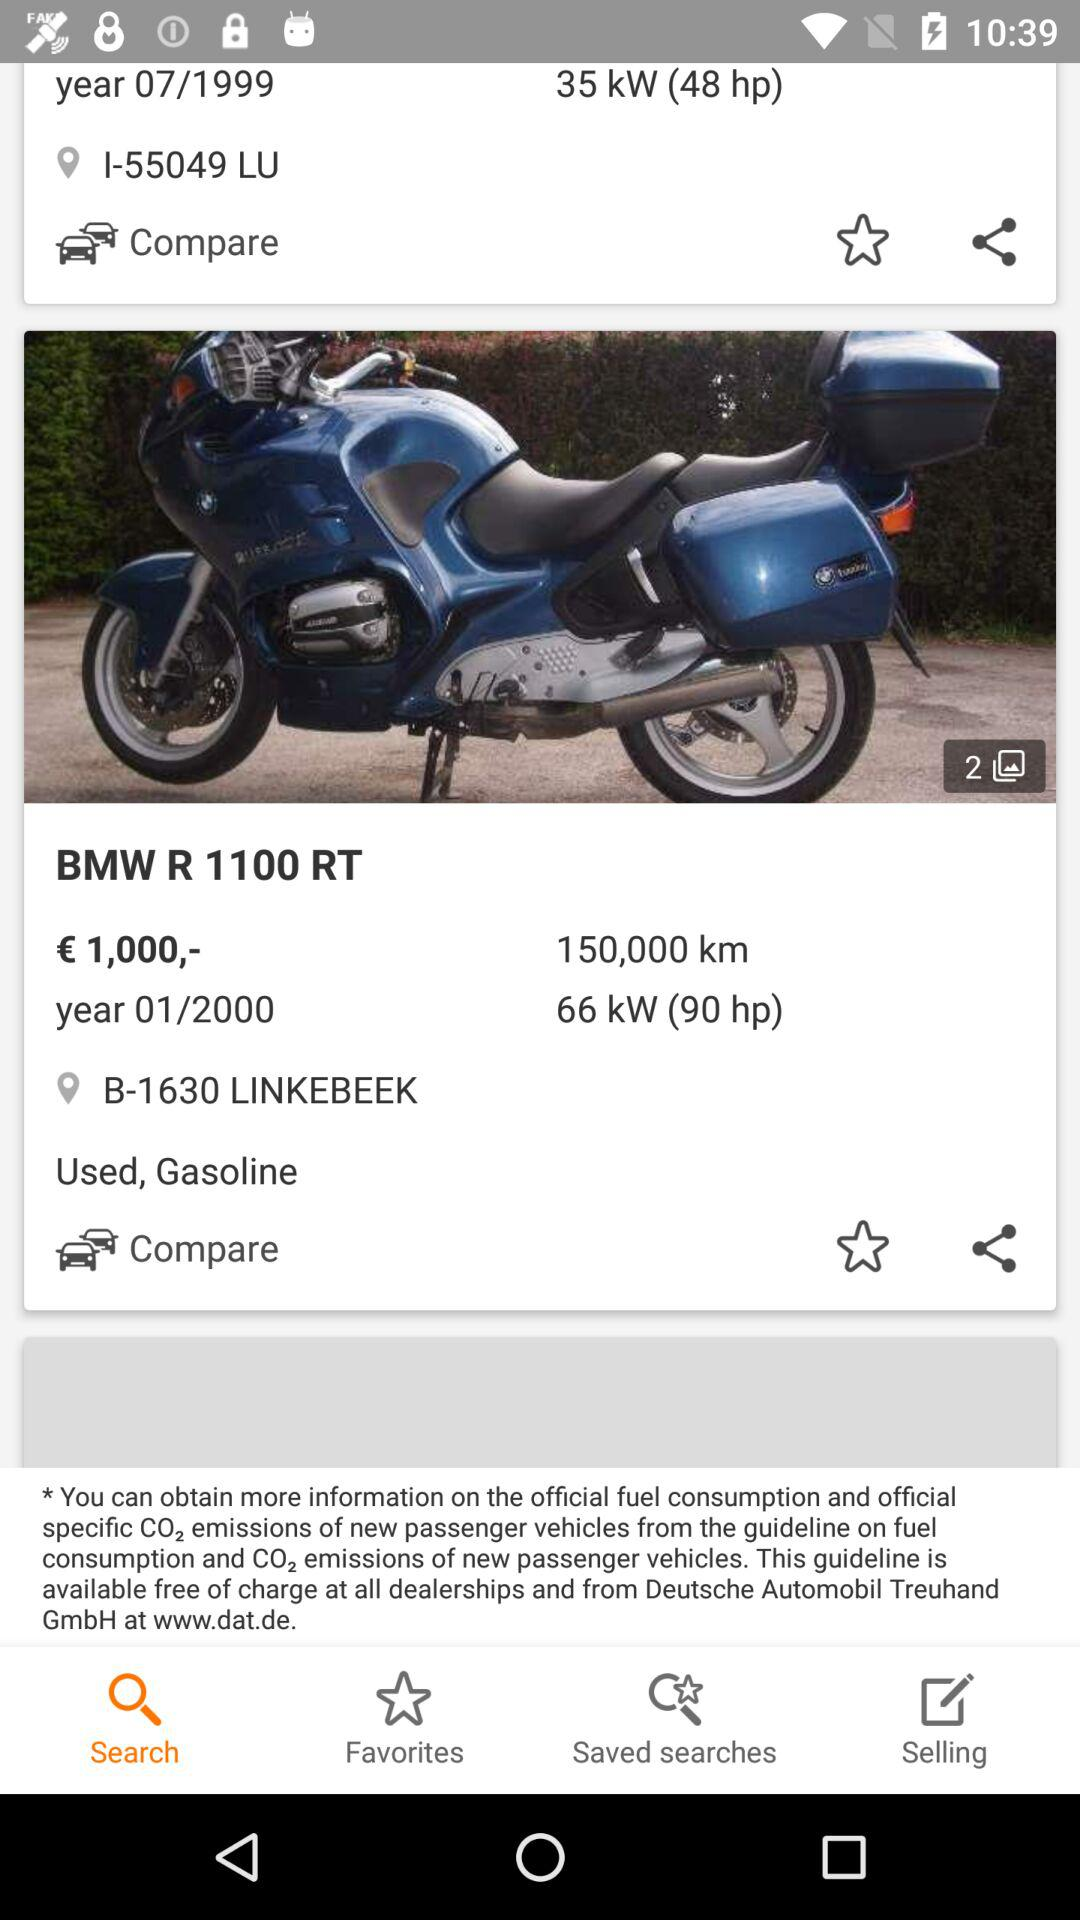What is the launch month and year? The launch month is July and the year is 1999. 